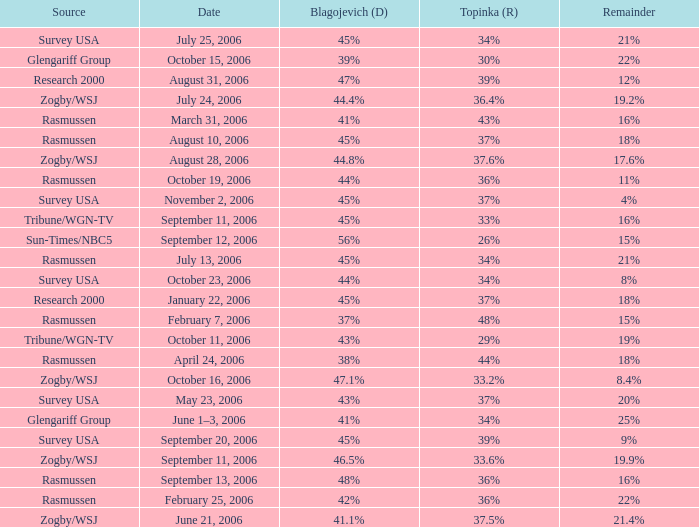Which event involving topinka occurred on january 22, 2006? 37%. Could you parse the entire table as a dict? {'header': ['Source', 'Date', 'Blagojevich (D)', 'Topinka (R)', 'Remainder'], 'rows': [['Survey USA', 'July 25, 2006', '45%', '34%', '21%'], ['Glengariff Group', 'October 15, 2006', '39%', '30%', '22%'], ['Research 2000', 'August 31, 2006', '47%', '39%', '12%'], ['Zogby/WSJ', 'July 24, 2006', '44.4%', '36.4%', '19.2%'], ['Rasmussen', 'March 31, 2006', '41%', '43%', '16%'], ['Rasmussen', 'August 10, 2006', '45%', '37%', '18%'], ['Zogby/WSJ', 'August 28, 2006', '44.8%', '37.6%', '17.6%'], ['Rasmussen', 'October 19, 2006', '44%', '36%', '11%'], ['Survey USA', 'November 2, 2006', '45%', '37%', '4%'], ['Tribune/WGN-TV', 'September 11, 2006', '45%', '33%', '16%'], ['Sun-Times/NBC5', 'September 12, 2006', '56%', '26%', '15%'], ['Rasmussen', 'July 13, 2006', '45%', '34%', '21%'], ['Survey USA', 'October 23, 2006', '44%', '34%', '8%'], ['Research 2000', 'January 22, 2006', '45%', '37%', '18%'], ['Rasmussen', 'February 7, 2006', '37%', '48%', '15%'], ['Tribune/WGN-TV', 'October 11, 2006', '43%', '29%', '19%'], ['Rasmussen', 'April 24, 2006', '38%', '44%', '18%'], ['Zogby/WSJ', 'October 16, 2006', '47.1%', '33.2%', '8.4%'], ['Survey USA', 'May 23, 2006', '43%', '37%', '20%'], ['Glengariff Group', 'June 1–3, 2006', '41%', '34%', '25%'], ['Survey USA', 'September 20, 2006', '45%', '39%', '9%'], ['Zogby/WSJ', 'September 11, 2006', '46.5%', '33.6%', '19.9%'], ['Rasmussen', 'September 13, 2006', '48%', '36%', '16%'], ['Rasmussen', 'February 25, 2006', '42%', '36%', '22%'], ['Zogby/WSJ', 'June 21, 2006', '41.1%', '37.5%', '21.4%']]} 